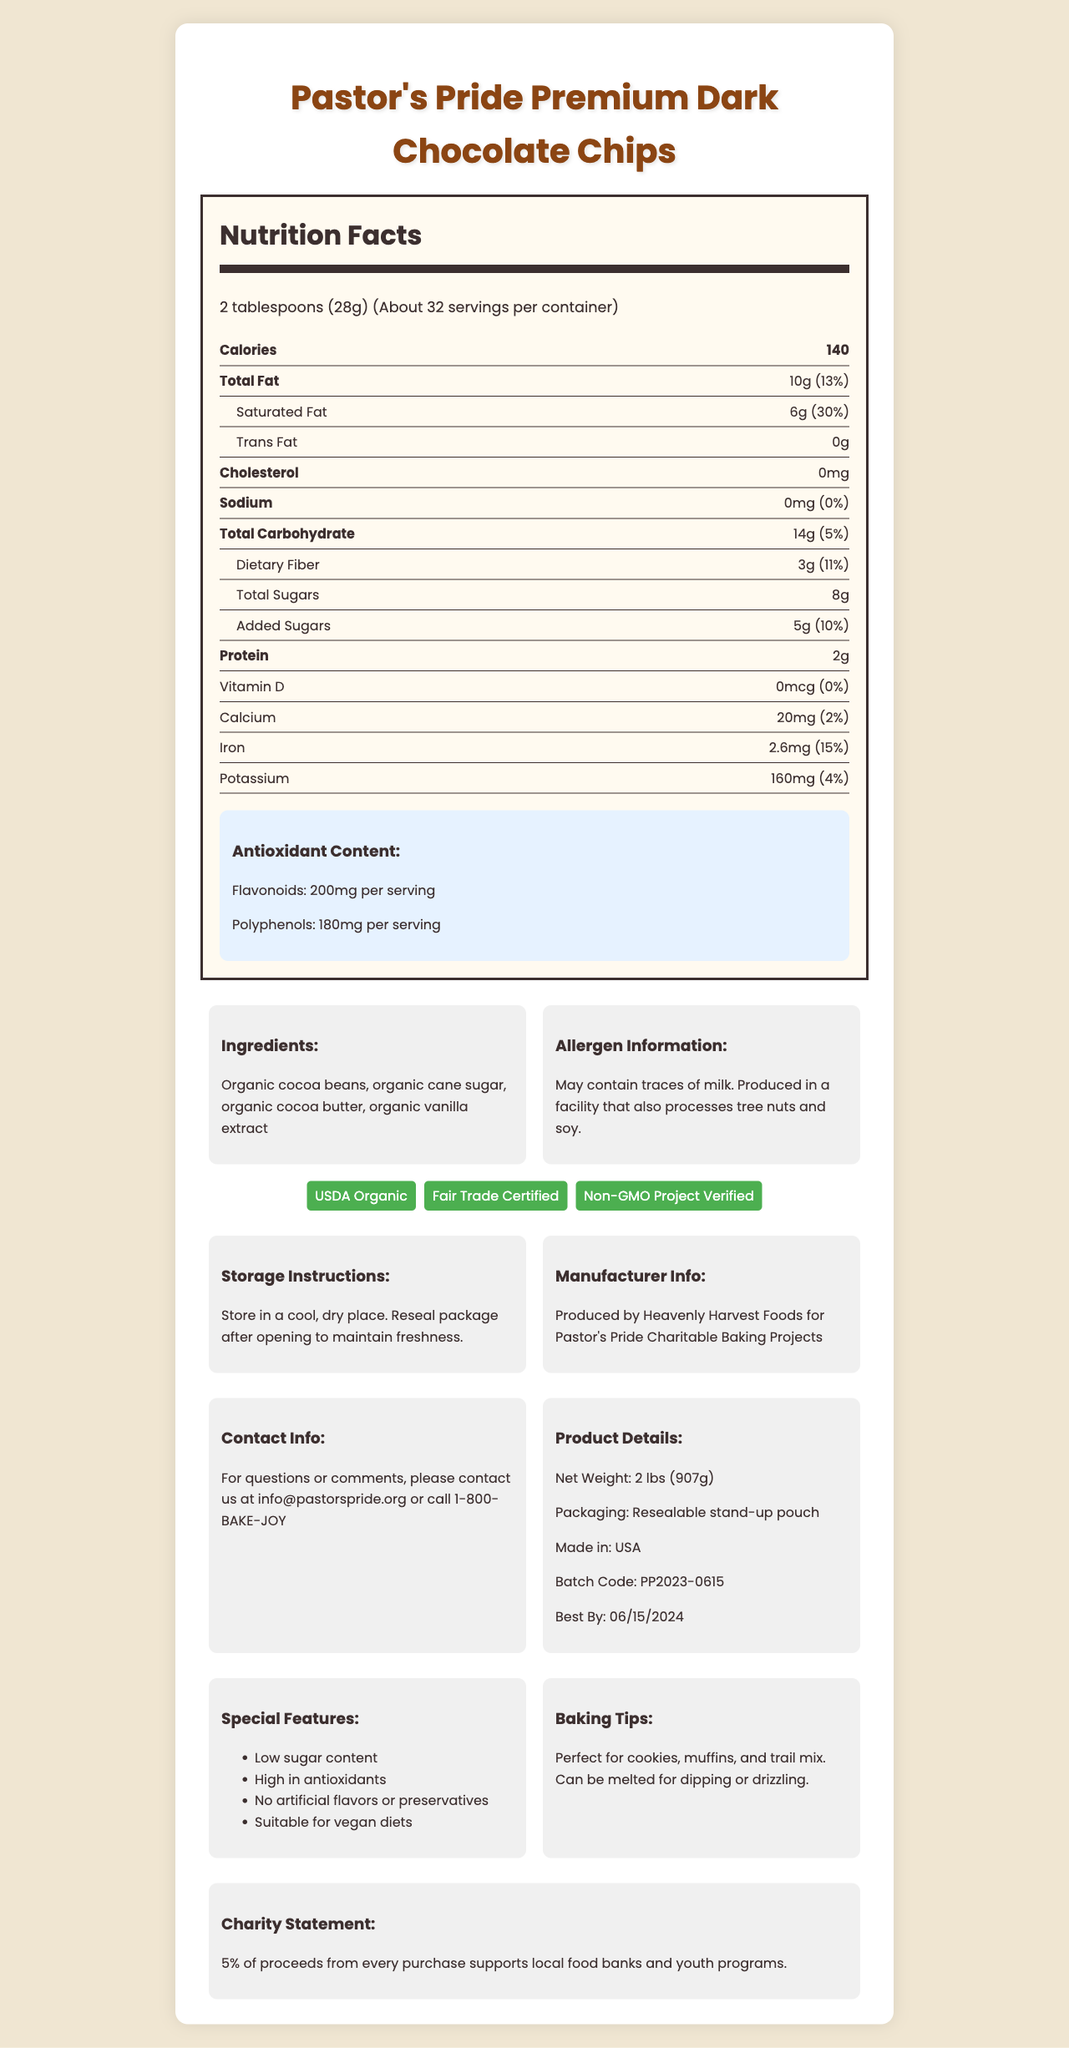what is the serving size? The serving size is stated directly in the "Nutrition Facts" section under "Serving Size".
Answer: 2 tablespoons (28g) how many calories are in one serving? The number of calories per serving is indicated clearly under "Calories" in the "Nutrition Facts" section.
Answer: 140 what percentage of the daily value of iron does one serving provide? The percentage of the daily value of iron is given under "Iron" in the "Nutrition Facts" section as 15%.
Answer: 15% how much dietary fiber is in a serving? The amount of dietary fiber per serving is listed under "Dietary Fiber" in the "Nutrition Facts" section.
Answer: 3g what is the total fat content per serving? The total fat content per serving is located under "Total Fat" in the "Nutrition Facts" section.
Answer: 10g how many grams of added sugars are in one serving? The added sugars per serving can be found under "Added Sugars" in the "Nutrition Facts" section as 5 grams.
Answer: 5g how much cholesterol is in one serving? The amount of cholesterol per serving is listed under "Cholesterol" in the "Nutrition Facts" section as 0mg.
Answer: 0mg what certifications does this product have? The certifications are mentioned in the "certifications" section of the document.
Answer: USDA Organic, Fair Trade Certified, Non-GMO Project Verified where should the chocolate chips be stored? The storage instructions are provided under "Storage Instructions" in the document.
Answer: In a cool, dry place. Reseal package after opening to maintain freshness. what is the best by date for this product? The best by date can be found in the "Product Details" section of the document.
Answer: 06/15/2024 how much potassium is in a serving? The amount of potassium per serving is listed under "Potassium" in the "Nutrition Facts" section as 160mg.
Answer: 160mg what percentage of the daily value of saturated fat is in one serving? The percentage of the daily value of saturated fat can be found under "Saturated Fat" in the "Nutrition Facts" section as 30%.
Answer: 30% which ingredient is not listed in the ingredient section? A. Organic Cocoa Beans B. Organic Cane Sugar C. Milk D. Organic Vanilla Extract The ingredients listed are Organic cocoa beans, organic cane sugar, organic cocoa butter, and organic vanilla extract, whereas milk is not mentioned.
Answer: C. Milk which antioxidant is present in the highest amount per serving? A. Flavonoids B. Polyphenols C. Dietary Fiber D. Iron Flavonoids are present at 200mg per serving, whereas polyphenols are at 180mg, dietary fiber at 3g, and iron at 2.6mg.
Answer: A. Flavonoids is this product suitable for vegan diets? The document states that the product is suitable for vegan diets under the "special features" section.
Answer: Yes does one serving contain any trans fat? The document denotes "Trans Fat 0g" under the "Nutrition Facts" section.
Answer: No summarize the purpose and contents of this document. The document includes comprehensive nutritional data, indications of antioxidants, and special features highlighting the product's organic and fair-trade certifications. It also details allergen information, storage instructions, manufacturer info, and contact details.
Answer: This document provides detailed nutritional information, certifications, ingredient list, storage instructions, and special features of Pastor's Pride Premium Dark Chocolate Chips, which are high in antioxidants and have low sugar content. who is the manufacturer of these chocolate chips? The manufacturer is mentioned in the "Manufacturer Info" section of the document.
Answer: Heavenly Harvest Foods for Pastor's Pride Charitable Baking Projects what percentage of total carbohydrates does one serving provide based on daily value? The document lists total carbohydrates per serving as 14g, which is 5% of the daily value.
Answer: 5% how much protein is in a serving? The amount of protein per serving is provided under the "Protein" section in the "Nutrition Facts" section.
Answer: 2g what is the email address for inquires or comments about this product? The contact email is listed in the "Contact Info" section of the document.
Answer: info@pastorspride.org what other products does this company manufacture? The document does not provide any information about other products manufactured by the company.
Answer: I don't know interpret the antioxidant content details. The section on antioxidant content states that each serving contains 200mg of flavonoids and 180mg of polyphenols.
Answer: Flavonoids: 200mg per serving, Polyphenols: 180mg per serving 